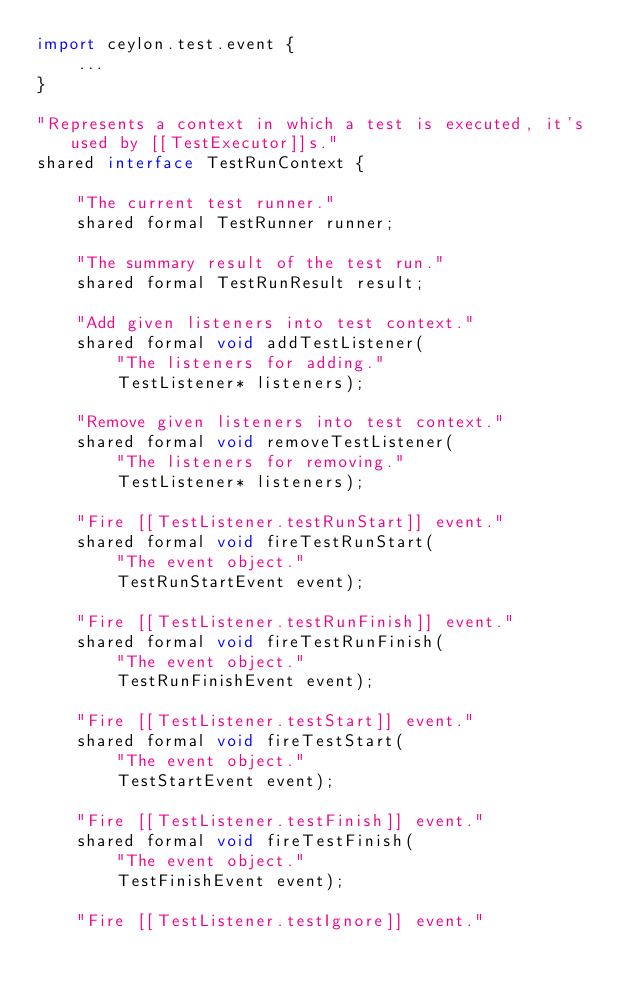Convert code to text. <code><loc_0><loc_0><loc_500><loc_500><_Ceylon_>import ceylon.test.event {
    ...
}

"Represents a context in which a test is executed, it's used by [[TestExecutor]]s."
shared interface TestRunContext {
    
    "The current test runner."
    shared formal TestRunner runner;
    
    "The summary result of the test run."
    shared formal TestRunResult result;
    
    "Add given listeners into test context."
    shared formal void addTestListener(
        "The listeners for adding."
        TestListener* listeners);
    
    "Remove given listeners into test context."
    shared formal void removeTestListener(
        "The listeners for removing."
        TestListener* listeners);
    
    "Fire [[TestListener.testRunStart]] event."
    shared formal void fireTestRunStart(
        "The event object."
        TestRunStartEvent event);
    
    "Fire [[TestListener.testRunFinish]] event."
    shared formal void fireTestRunFinish(
        "The event object."
        TestRunFinishEvent event);
    
    "Fire [[TestListener.testStart]] event."
    shared formal void fireTestStart(
        "The event object."
        TestStartEvent event);
    
    "Fire [[TestListener.testFinish]] event."
    shared formal void fireTestFinish(
        "The event object."
        TestFinishEvent event);
    
    "Fire [[TestListener.testIgnore]] event."</code> 